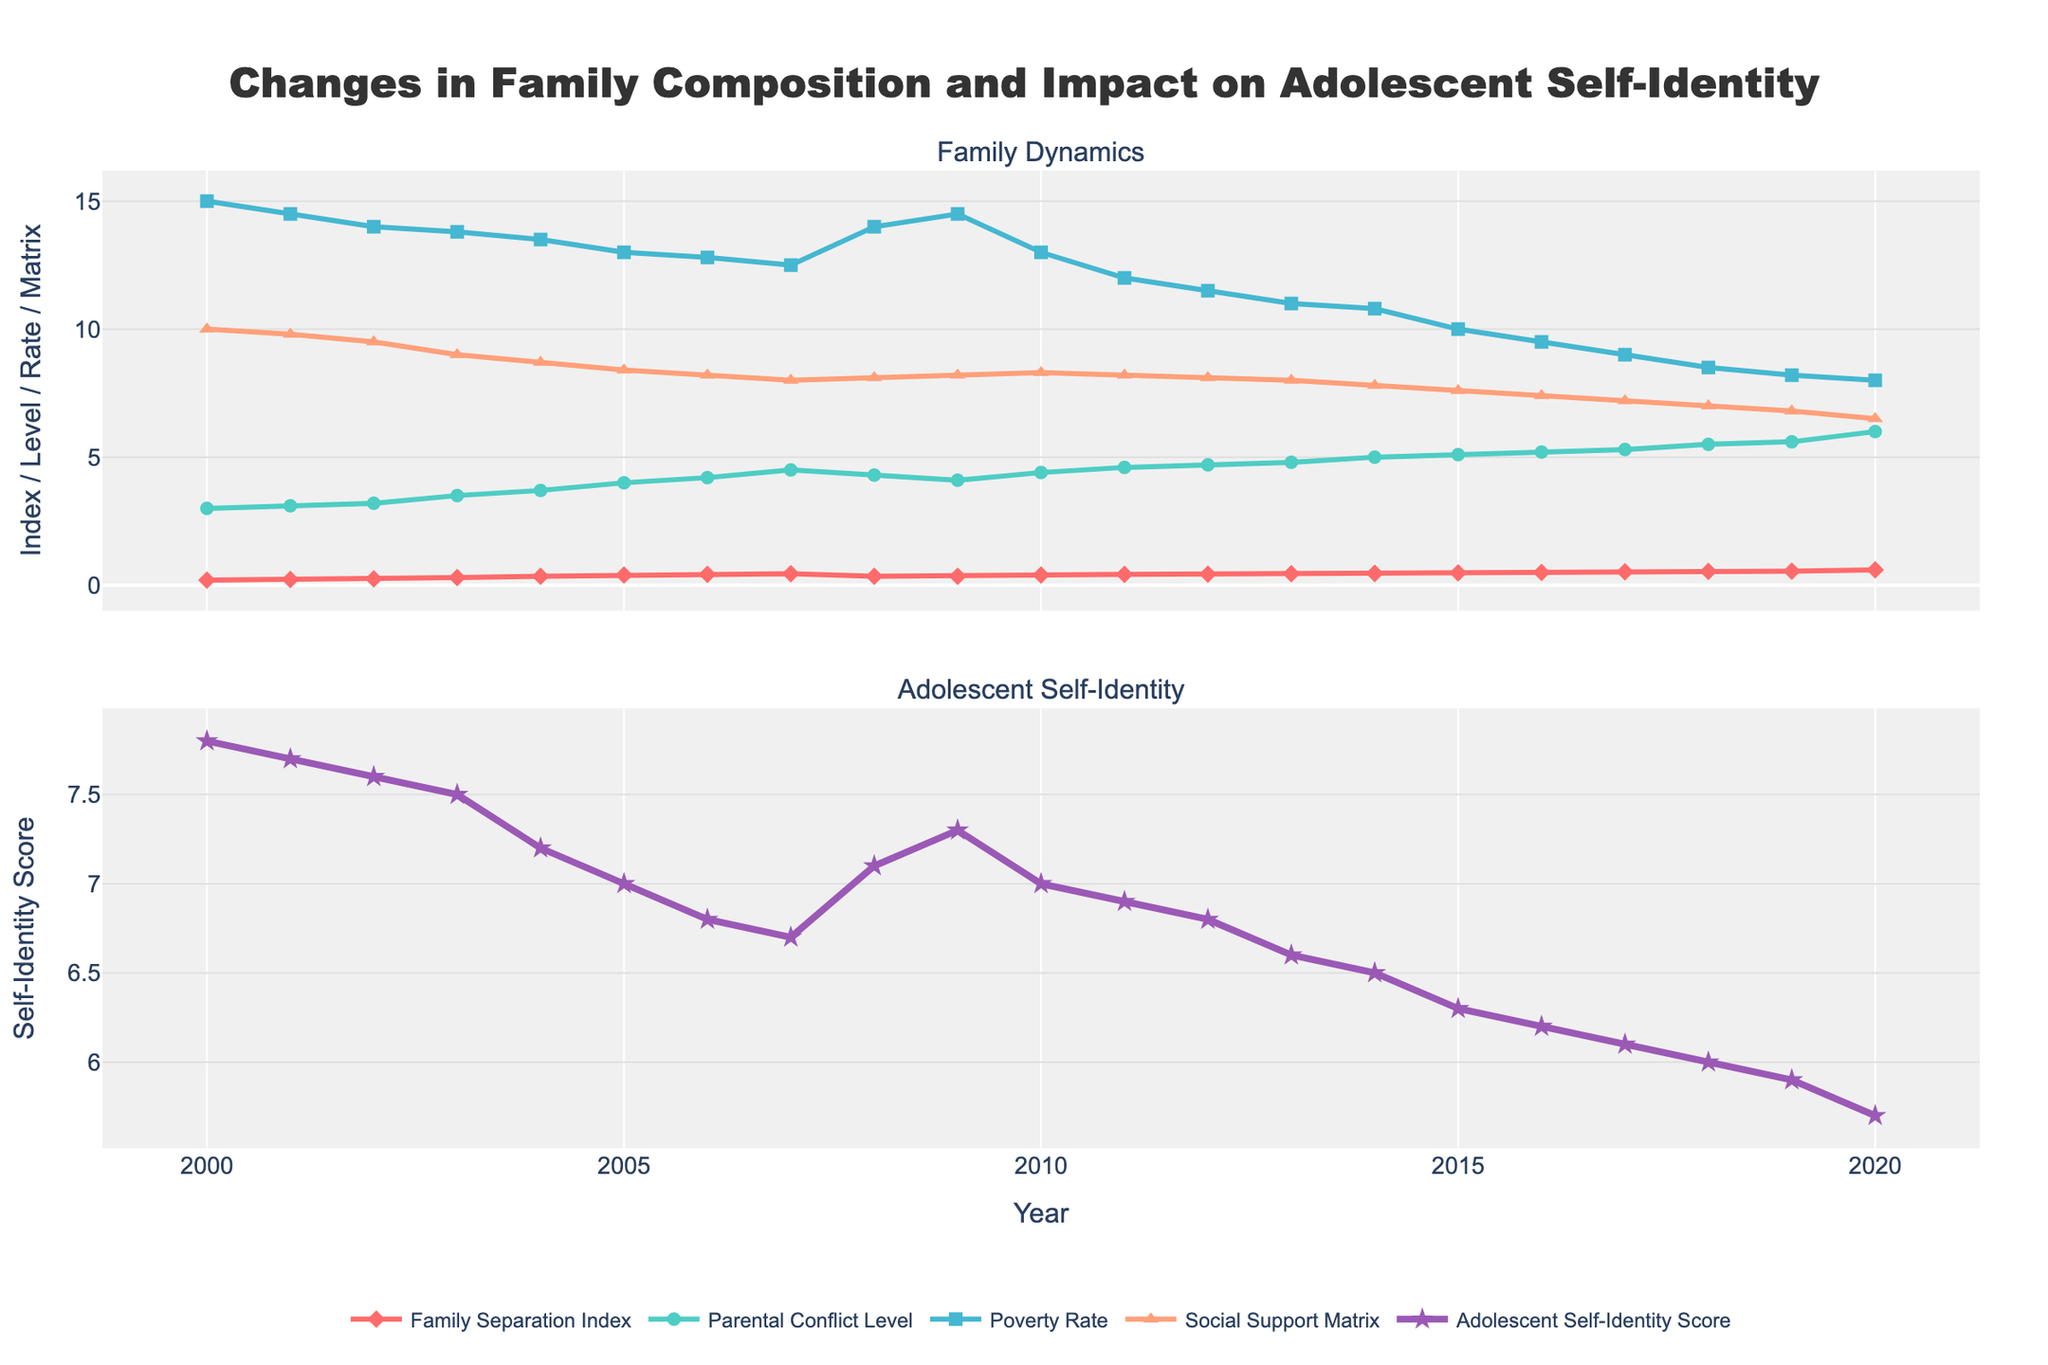What is the title of the plot? The title of the plot is positioned at the top and provides an overall description of the visualized data. It summarizes the subject of the graph.
Answer: Changes in Family Composition and Impact on Adolescent Self-Identity How many lines are displayed in the first subplot? The first subplot has multiple lines representing different indices and levels. By counting the distinct lines, we can determine the answer.
Answer: Four Which year has the highest Family Separation Index? To find this, identify the peak point on the Family Separation Index line in the first subplot. The x-axis value at this peak point is the year of interest.
Answer: 2020 Has the Adolescent Self-Identity Score increased or decreased over time? Observe the trend of the Adolescent Self-Identity Score line in the second subplot from the start to the end. If the line trends downward, it has decreased.
Answer: Decreased What is the average Parental Conflict Level between 2015 and 2020? First, look up the Parental Conflict Level values for 2015 to 2020. Then, sum these values and divide by the number of years to get the average. Values: 5.1, 5.2, 5.3, 5.5, 5.6, 6. Average = (5.1 + 5.2 + 5.3 + 5.5 + 5.6 + 6)/6
Answer: 5.45 What is the difference between the highest and lowest Adolescent Self-Identity Scores? Locate the highest and lowest points on the Adolescent Self-Identity Score line in the second subplot. Subtract the lowest score from the highest score. Highest: 7.8 (2000), Lowest: 5.7 (2020). Difference = 7.8 - 5.7
Answer: 2.1 How does the Family Separation Index compare to the Parental Conflict Level in 2019? Find the data for 2019 for both indices. Compare these values to determine if one is greater than, less than, or equal to the other. Family Separation Index: 0.55, Parental Conflict Level: 5.6
Answer: Parental Conflict Level is higher What was the trend of the Social Support Matrix from 2000 to 2010? Examine the line representing the Social Support Matrix in the first subplot from 2000 to 2010 and identify if it trends upwards, downwards, or remains stable.
Answer: Decreasing Which year has the lowest Poverty Rate? Identify the lowest point on the Poverty Rate line and note the corresponding year on the x-axis.
Answer: 2018 During which years did the Adolescent Self-Identity Score remain constant? Locate the points on the Adolescent Self-Identity Score line where the value remains unchanged over consecutive years.
Answer: 2007 to 2008 